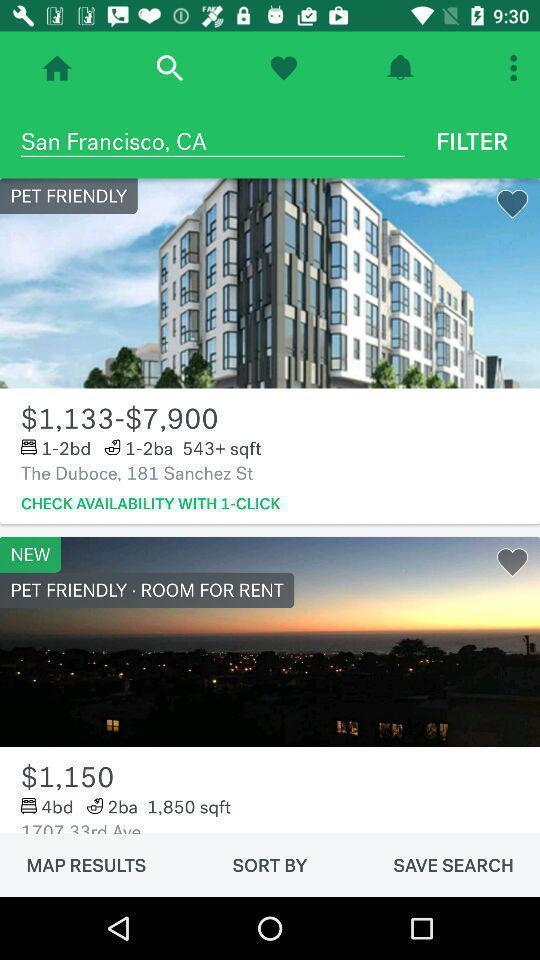Tell me about the visual elements in this screen capture. Page displaying rooms for rent information. 